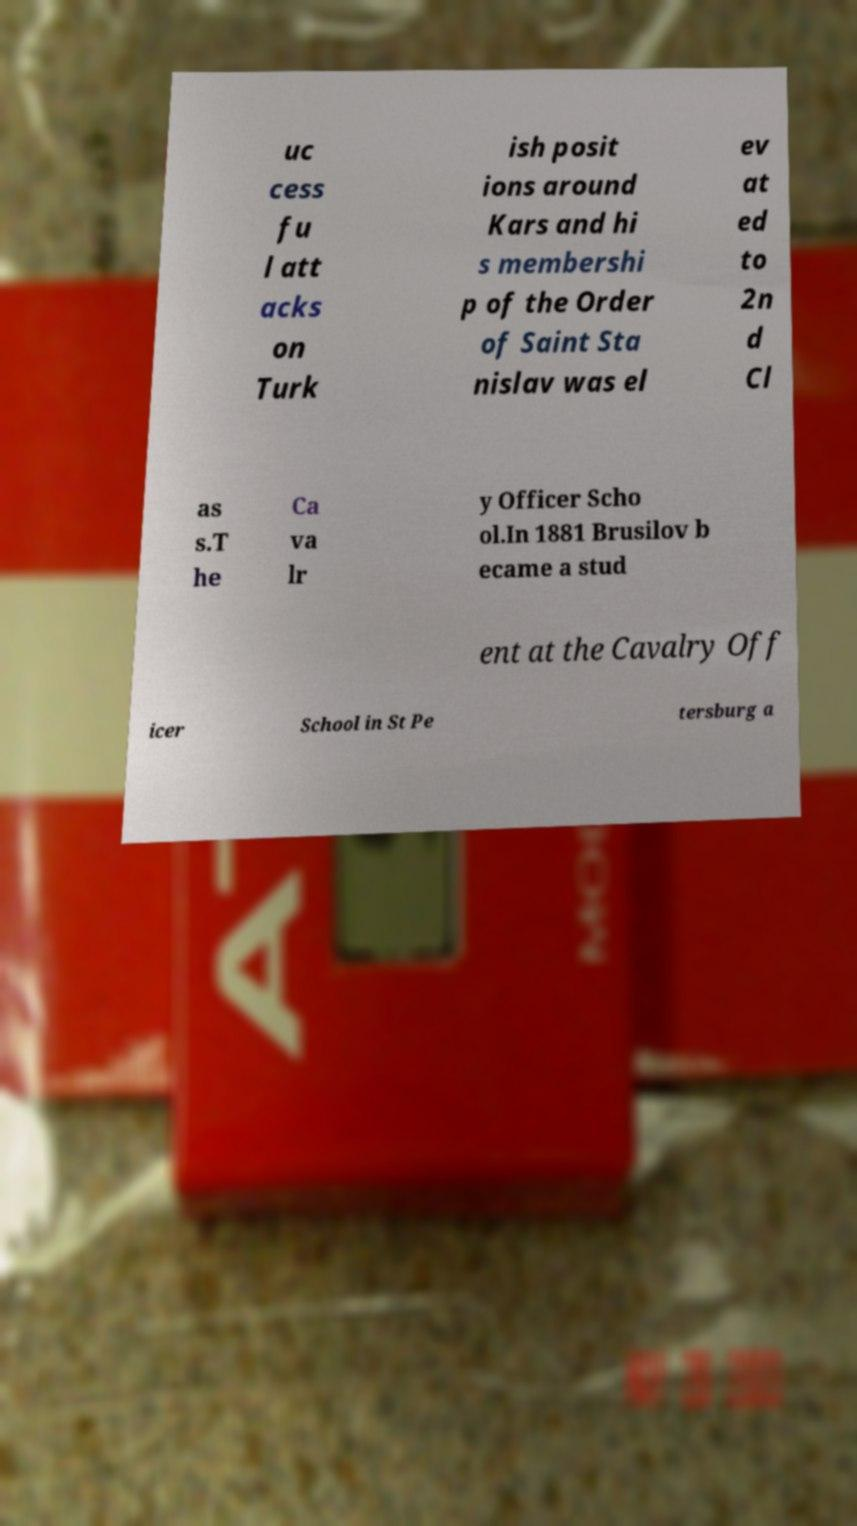There's text embedded in this image that I need extracted. Can you transcribe it verbatim? uc cess fu l att acks on Turk ish posit ions around Kars and hi s membershi p of the Order of Saint Sta nislav was el ev at ed to 2n d Cl as s.T he Ca va lr y Officer Scho ol.In 1881 Brusilov b ecame a stud ent at the Cavalry Off icer School in St Pe tersburg a 